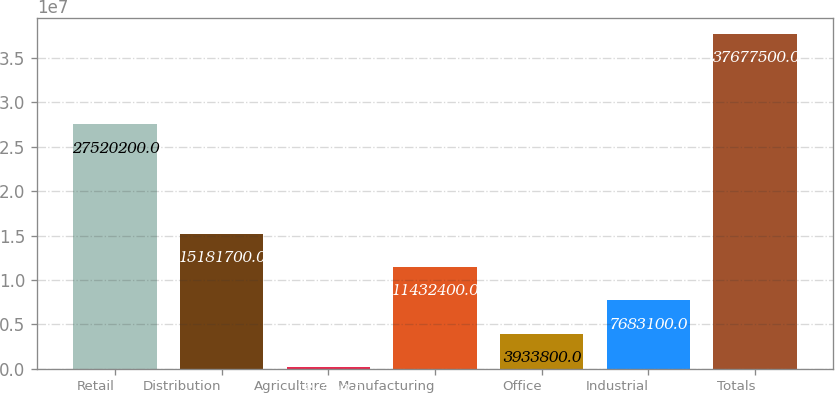Convert chart to OTSL. <chart><loc_0><loc_0><loc_500><loc_500><bar_chart><fcel>Retail<fcel>Distribution<fcel>Agriculture<fcel>Manufacturing<fcel>Office<fcel>Industrial<fcel>Totals<nl><fcel>2.75202e+07<fcel>1.51817e+07<fcel>184500<fcel>1.14324e+07<fcel>3.9338e+06<fcel>7.6831e+06<fcel>3.76775e+07<nl></chart> 